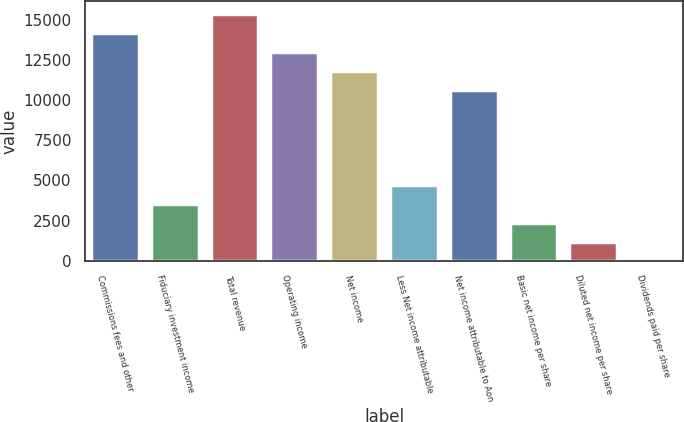<chart> <loc_0><loc_0><loc_500><loc_500><bar_chart><fcel>Commissions fees and other<fcel>Fiduciary investment income<fcel>Total revenue<fcel>Operating income<fcel>Net income<fcel>Less Net income attributable<fcel>Net income attributable to Aon<fcel>Basic net income per share<fcel>Diluted net income per share<fcel>Dividends paid per share<nl><fcel>14177.8<fcel>3544.97<fcel>15359.3<fcel>12996.4<fcel>11815<fcel>4726.4<fcel>10633.5<fcel>2363.54<fcel>1182.11<fcel>0.68<nl></chart> 